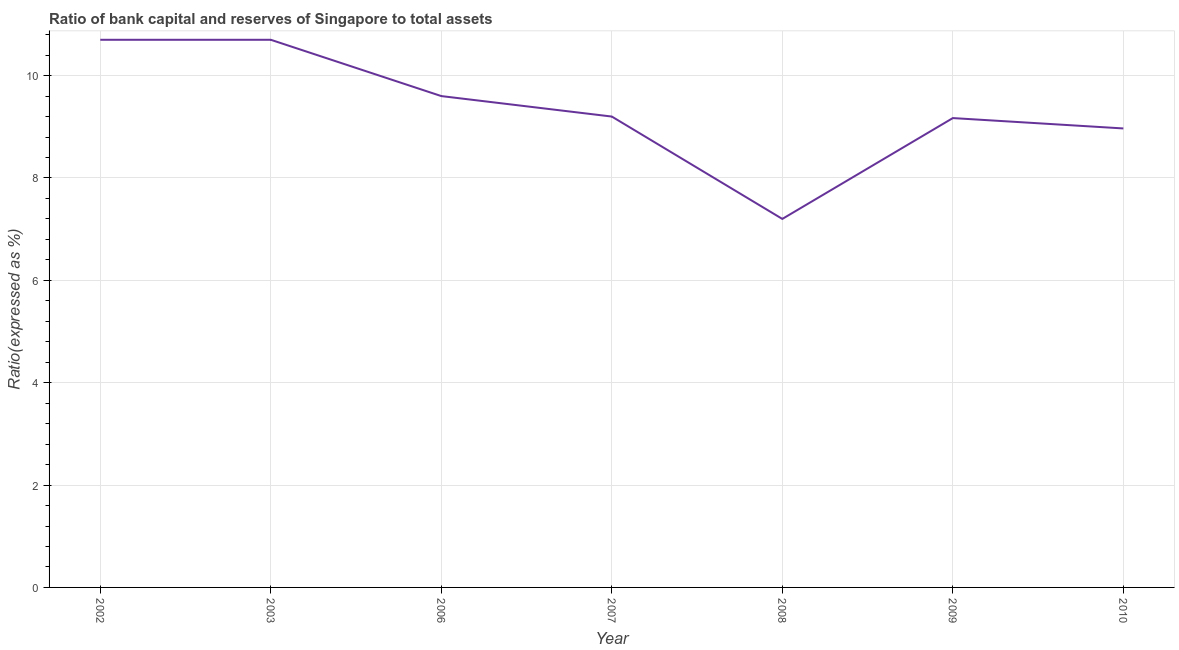What is the bank capital to assets ratio in 2009?
Make the answer very short. 9.17. Across all years, what is the minimum bank capital to assets ratio?
Your response must be concise. 7.2. In which year was the bank capital to assets ratio maximum?
Keep it short and to the point. 2002. In which year was the bank capital to assets ratio minimum?
Offer a terse response. 2008. What is the sum of the bank capital to assets ratio?
Provide a succinct answer. 65.54. What is the difference between the bank capital to assets ratio in 2003 and 2010?
Provide a succinct answer. 1.73. What is the average bank capital to assets ratio per year?
Provide a succinct answer. 9.36. In how many years, is the bank capital to assets ratio greater than 2.4 %?
Your answer should be compact. 7. What is the ratio of the bank capital to assets ratio in 2007 to that in 2008?
Offer a very short reply. 1.28. What is the difference between the highest and the lowest bank capital to assets ratio?
Offer a very short reply. 3.5. In how many years, is the bank capital to assets ratio greater than the average bank capital to assets ratio taken over all years?
Offer a terse response. 3. How many years are there in the graph?
Ensure brevity in your answer.  7. Are the values on the major ticks of Y-axis written in scientific E-notation?
Keep it short and to the point. No. Does the graph contain grids?
Provide a short and direct response. Yes. What is the title of the graph?
Your response must be concise. Ratio of bank capital and reserves of Singapore to total assets. What is the label or title of the Y-axis?
Offer a very short reply. Ratio(expressed as %). What is the Ratio(expressed as %) of 2002?
Your response must be concise. 10.7. What is the Ratio(expressed as %) in 2006?
Provide a short and direct response. 9.6. What is the Ratio(expressed as %) in 2009?
Your answer should be compact. 9.17. What is the Ratio(expressed as %) of 2010?
Provide a succinct answer. 8.97. What is the difference between the Ratio(expressed as %) in 2002 and 2003?
Provide a short and direct response. 0. What is the difference between the Ratio(expressed as %) in 2002 and 2007?
Provide a short and direct response. 1.5. What is the difference between the Ratio(expressed as %) in 2002 and 2009?
Give a very brief answer. 1.53. What is the difference between the Ratio(expressed as %) in 2002 and 2010?
Ensure brevity in your answer.  1.73. What is the difference between the Ratio(expressed as %) in 2003 and 2006?
Your response must be concise. 1.1. What is the difference between the Ratio(expressed as %) in 2003 and 2008?
Give a very brief answer. 3.5. What is the difference between the Ratio(expressed as %) in 2003 and 2009?
Your answer should be compact. 1.53. What is the difference between the Ratio(expressed as %) in 2003 and 2010?
Provide a succinct answer. 1.73. What is the difference between the Ratio(expressed as %) in 2006 and 2009?
Give a very brief answer. 0.43. What is the difference between the Ratio(expressed as %) in 2006 and 2010?
Offer a terse response. 0.63. What is the difference between the Ratio(expressed as %) in 2007 and 2008?
Your answer should be compact. 2. What is the difference between the Ratio(expressed as %) in 2007 and 2009?
Give a very brief answer. 0.03. What is the difference between the Ratio(expressed as %) in 2007 and 2010?
Make the answer very short. 0.23. What is the difference between the Ratio(expressed as %) in 2008 and 2009?
Offer a terse response. -1.97. What is the difference between the Ratio(expressed as %) in 2008 and 2010?
Ensure brevity in your answer.  -1.77. What is the difference between the Ratio(expressed as %) in 2009 and 2010?
Ensure brevity in your answer.  0.2. What is the ratio of the Ratio(expressed as %) in 2002 to that in 2006?
Keep it short and to the point. 1.11. What is the ratio of the Ratio(expressed as %) in 2002 to that in 2007?
Provide a short and direct response. 1.16. What is the ratio of the Ratio(expressed as %) in 2002 to that in 2008?
Your response must be concise. 1.49. What is the ratio of the Ratio(expressed as %) in 2002 to that in 2009?
Offer a terse response. 1.17. What is the ratio of the Ratio(expressed as %) in 2002 to that in 2010?
Provide a succinct answer. 1.19. What is the ratio of the Ratio(expressed as %) in 2003 to that in 2006?
Offer a terse response. 1.11. What is the ratio of the Ratio(expressed as %) in 2003 to that in 2007?
Provide a short and direct response. 1.16. What is the ratio of the Ratio(expressed as %) in 2003 to that in 2008?
Keep it short and to the point. 1.49. What is the ratio of the Ratio(expressed as %) in 2003 to that in 2009?
Ensure brevity in your answer.  1.17. What is the ratio of the Ratio(expressed as %) in 2003 to that in 2010?
Your answer should be very brief. 1.19. What is the ratio of the Ratio(expressed as %) in 2006 to that in 2007?
Your answer should be compact. 1.04. What is the ratio of the Ratio(expressed as %) in 2006 to that in 2008?
Offer a very short reply. 1.33. What is the ratio of the Ratio(expressed as %) in 2006 to that in 2009?
Provide a succinct answer. 1.05. What is the ratio of the Ratio(expressed as %) in 2006 to that in 2010?
Make the answer very short. 1.07. What is the ratio of the Ratio(expressed as %) in 2007 to that in 2008?
Make the answer very short. 1.28. What is the ratio of the Ratio(expressed as %) in 2007 to that in 2010?
Your answer should be very brief. 1.03. What is the ratio of the Ratio(expressed as %) in 2008 to that in 2009?
Your answer should be compact. 0.79. What is the ratio of the Ratio(expressed as %) in 2008 to that in 2010?
Your answer should be very brief. 0.8. 